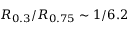Convert formula to latex. <formula><loc_0><loc_0><loc_500><loc_500>R _ { 0 . 3 } / R _ { 0 . 7 5 } \sim 1 / 6 . 2</formula> 